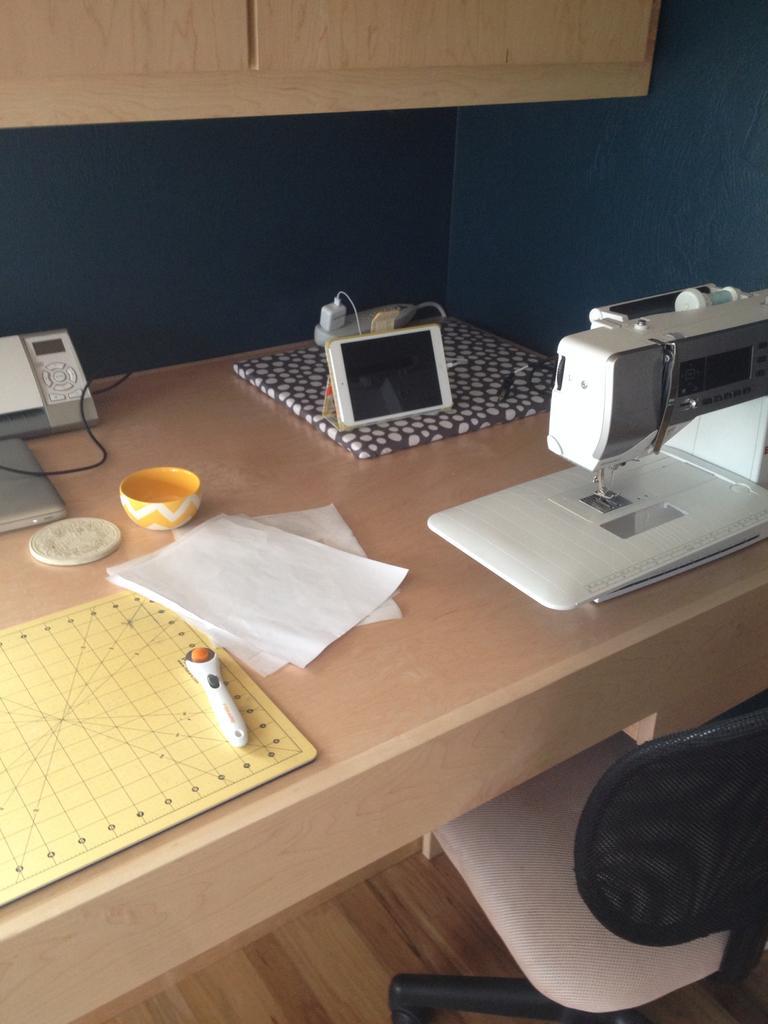Describe this image in one or two sentences. In this image I can see a chair and the cream colored table. On the table I can see few papers, a sewing machine, a bowl, a telephone, a tab, few paper and few other objects. I can see the wall and a wooden cabinet. 